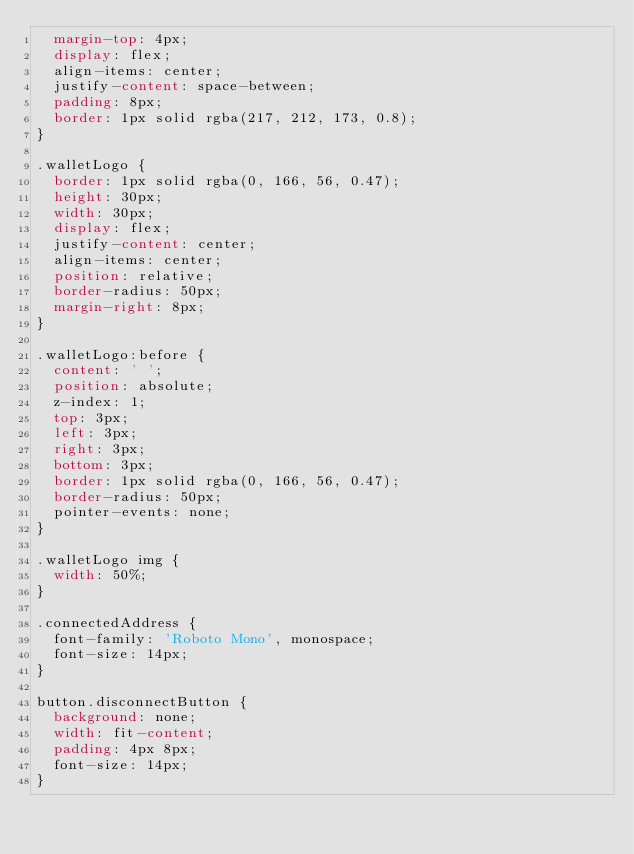Convert code to text. <code><loc_0><loc_0><loc_500><loc_500><_CSS_>  margin-top: 4px;
  display: flex;
  align-items: center;
  justify-content: space-between;
  padding: 8px;
  border: 1px solid rgba(217, 212, 173, 0.8);
}

.walletLogo {
  border: 1px solid rgba(0, 166, 56, 0.47);
  height: 30px;
  width: 30px;
  display: flex;
  justify-content: center;
  align-items: center;
  position: relative;
  border-radius: 50px;
  margin-right: 8px;
}

.walletLogo:before {
  content: ' ';
  position: absolute;
  z-index: 1;
  top: 3px;
  left: 3px;
  right: 3px;
  bottom: 3px;
  border: 1px solid rgba(0, 166, 56, 0.47);
  border-radius: 50px;
  pointer-events: none;
}

.walletLogo img {
  width: 50%;
}

.connectedAddress {
  font-family: 'Roboto Mono', monospace;
  font-size: 14px;
}

button.disconnectButton {
  background: none;
  width: fit-content;
  padding: 4px 8px;
  font-size: 14px;
}
</code> 